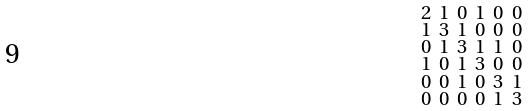<formula> <loc_0><loc_0><loc_500><loc_500>\begin{smallmatrix} 2 & 1 & 0 & 1 & 0 & 0 \\ 1 & 3 & 1 & 0 & 0 & 0 \\ 0 & 1 & 3 & 1 & 1 & 0 \\ 1 & 0 & 1 & 3 & 0 & 0 \\ 0 & 0 & 1 & 0 & 3 & 1 \\ 0 & 0 & 0 & 0 & 1 & 3 \end{smallmatrix}</formula> 